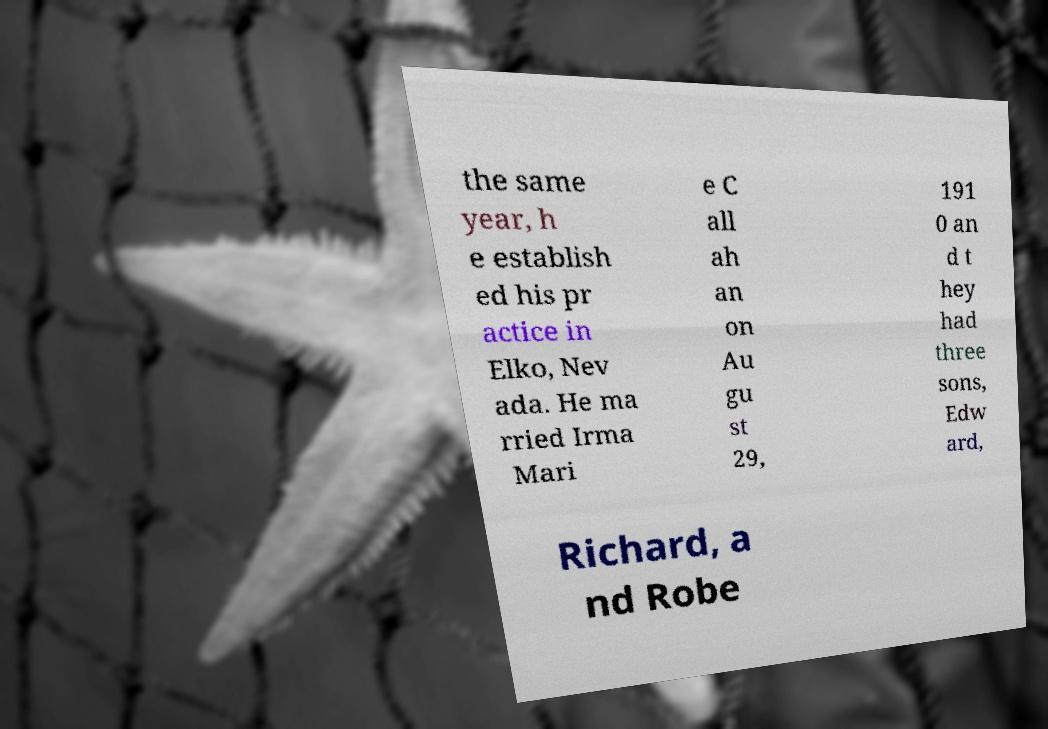I need the written content from this picture converted into text. Can you do that? the same year, h e establish ed his pr actice in Elko, Nev ada. He ma rried Irma Mari e C all ah an on Au gu st 29, 191 0 an d t hey had three sons, Edw ard, Richard, a nd Robe 